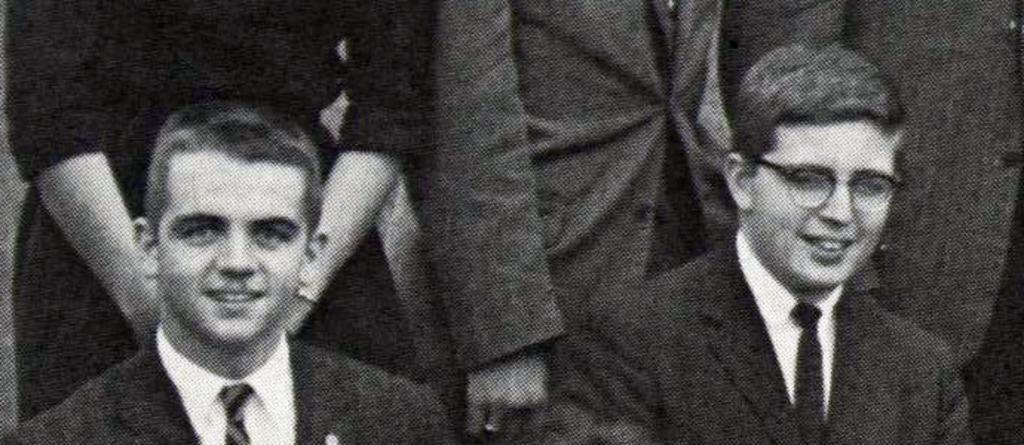What is the color scheme of the image? The image is black and white. How many people can be seen at the bottom of the image? There are two persons at the bottom of the image. Are there any other people visible in the image? Yes, there are some persons standing in the background of the image. What type of flame can be seen in the eyes of the person at the bottom of the image? There is no flame or any reference to eyes in the image; it is a black and white image with two persons at the bottom and some persons in the background. 